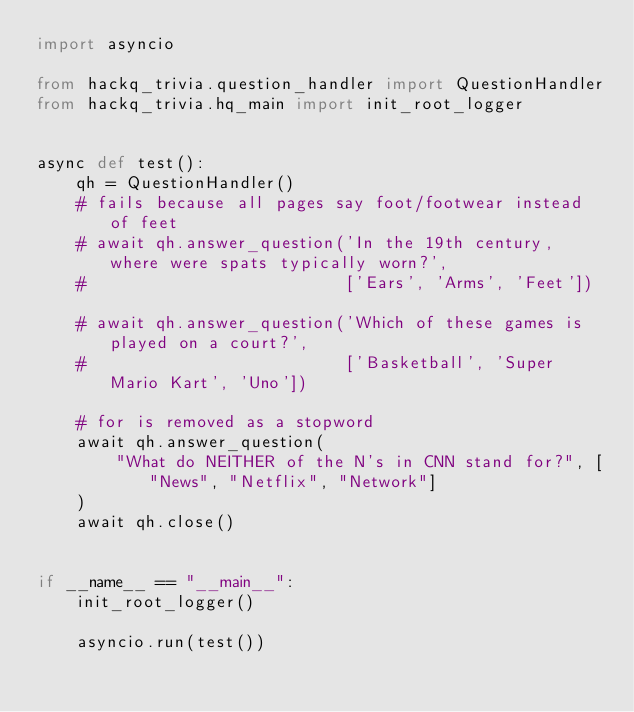<code> <loc_0><loc_0><loc_500><loc_500><_Python_>import asyncio

from hackq_trivia.question_handler import QuestionHandler
from hackq_trivia.hq_main import init_root_logger


async def test():
    qh = QuestionHandler()
    # fails because all pages say foot/footwear instead of feet
    # await qh.answer_question('In the 19th century, where were spats typically worn?',
    #                          ['Ears', 'Arms', 'Feet'])

    # await qh.answer_question('Which of these games is played on a court?',
    #                          ['Basketball', 'Super Mario Kart', 'Uno'])

    # for is removed as a stopword
    await qh.answer_question(
        "What do NEITHER of the N's in CNN stand for?", ["News", "Netflix", "Network"]
    )
    await qh.close()


if __name__ == "__main__":
    init_root_logger()

    asyncio.run(test())
</code> 